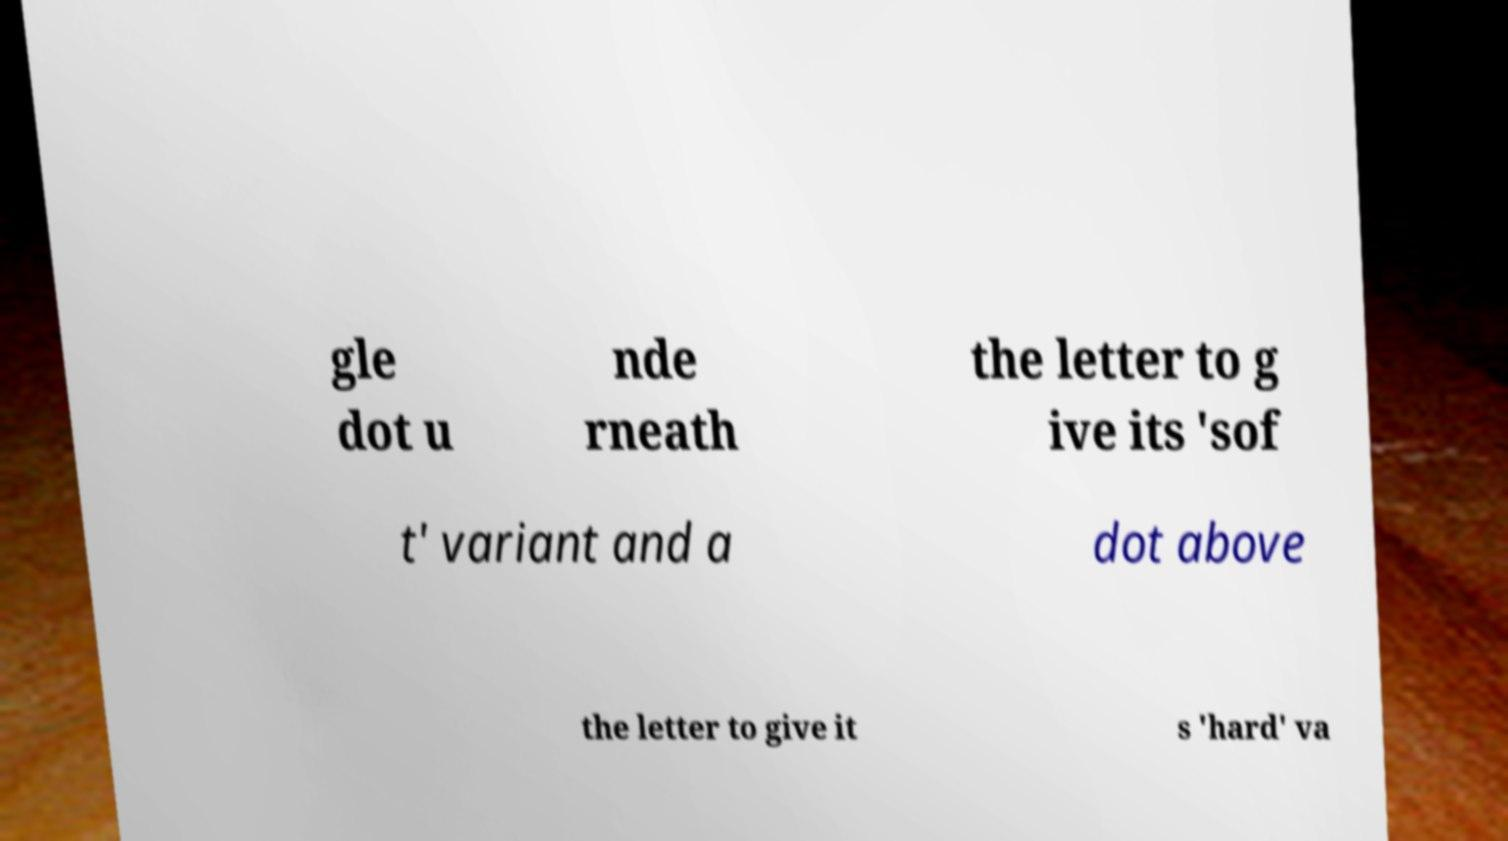For documentation purposes, I need the text within this image transcribed. Could you provide that? gle dot u nde rneath the letter to g ive its 'sof t' variant and a dot above the letter to give it s 'hard' va 